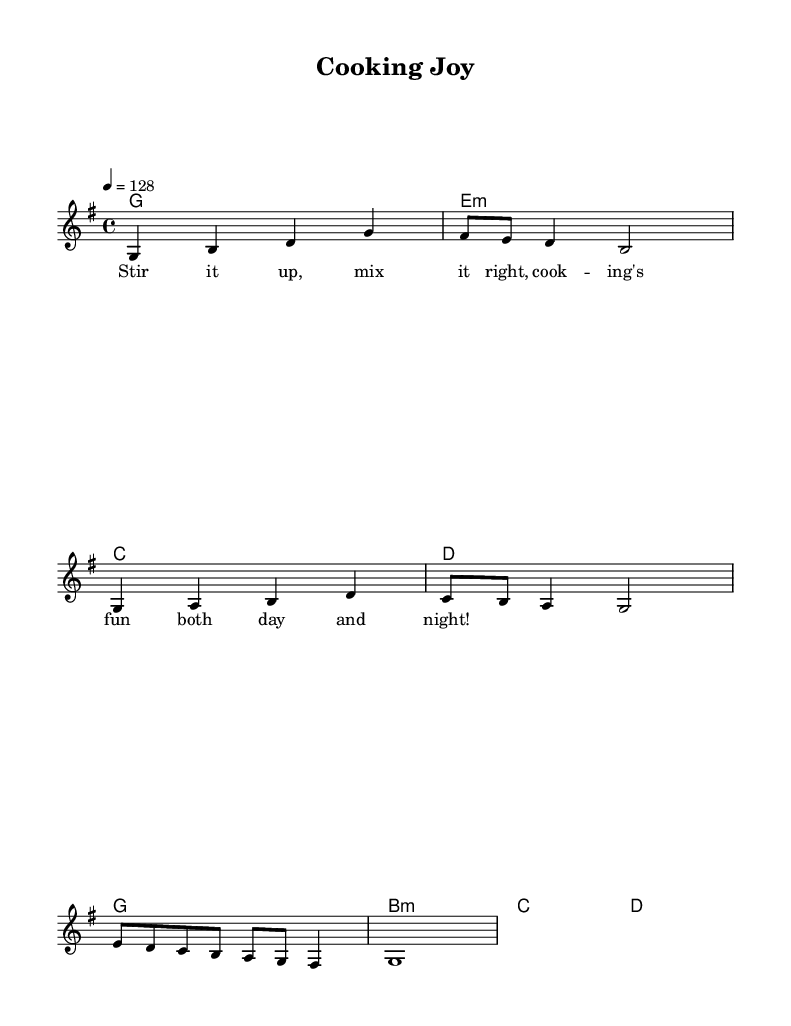What is the key signature of this music? The key signature is G major, which has one sharp (F#).
Answer: G major What is the time signature of the piece? The time signature is 4/4, indicating four beats in a measure.
Answer: 4/4 What is the tempo marking for this music? The tempo marking is 128 beats per minute, indicated by "4 = 128".
Answer: 128 How many measures are in the melody? The melody consists of 8 measures, as indicated by the number of groupings of notes.
Answer: 8 What is the main theme described in the lyrics? The lyrics celebrate cooking and the joy of learning, emphasizing mixing and stirring ingredients.
Answer: Cooking joy In which section do the harmonies change? The harmonies change occur every measure, as indicated by the chord changes listed below the staff.
Answer: Each measure What type of feeling does this K-Pop song convey according to its lyrics? The lyrics convey a joyful and fun feeling about cooking, reflecting enthusiasm and excitement.
Answer: Joyful 